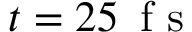Convert formula to latex. <formula><loc_0><loc_0><loc_500><loc_500>t = 2 5 \, f s</formula> 